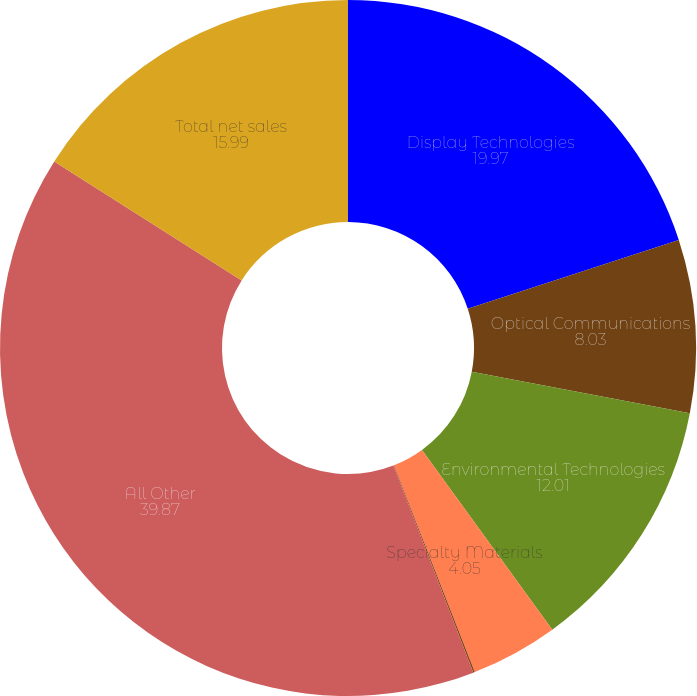Convert chart to OTSL. <chart><loc_0><loc_0><loc_500><loc_500><pie_chart><fcel>Display Technologies<fcel>Optical Communications<fcel>Environmental Technologies<fcel>Specialty Materials<fcel>Life Sciences<fcel>All Other<fcel>Total net sales<nl><fcel>19.97%<fcel>8.03%<fcel>12.01%<fcel>4.05%<fcel>0.07%<fcel>39.87%<fcel>15.99%<nl></chart> 